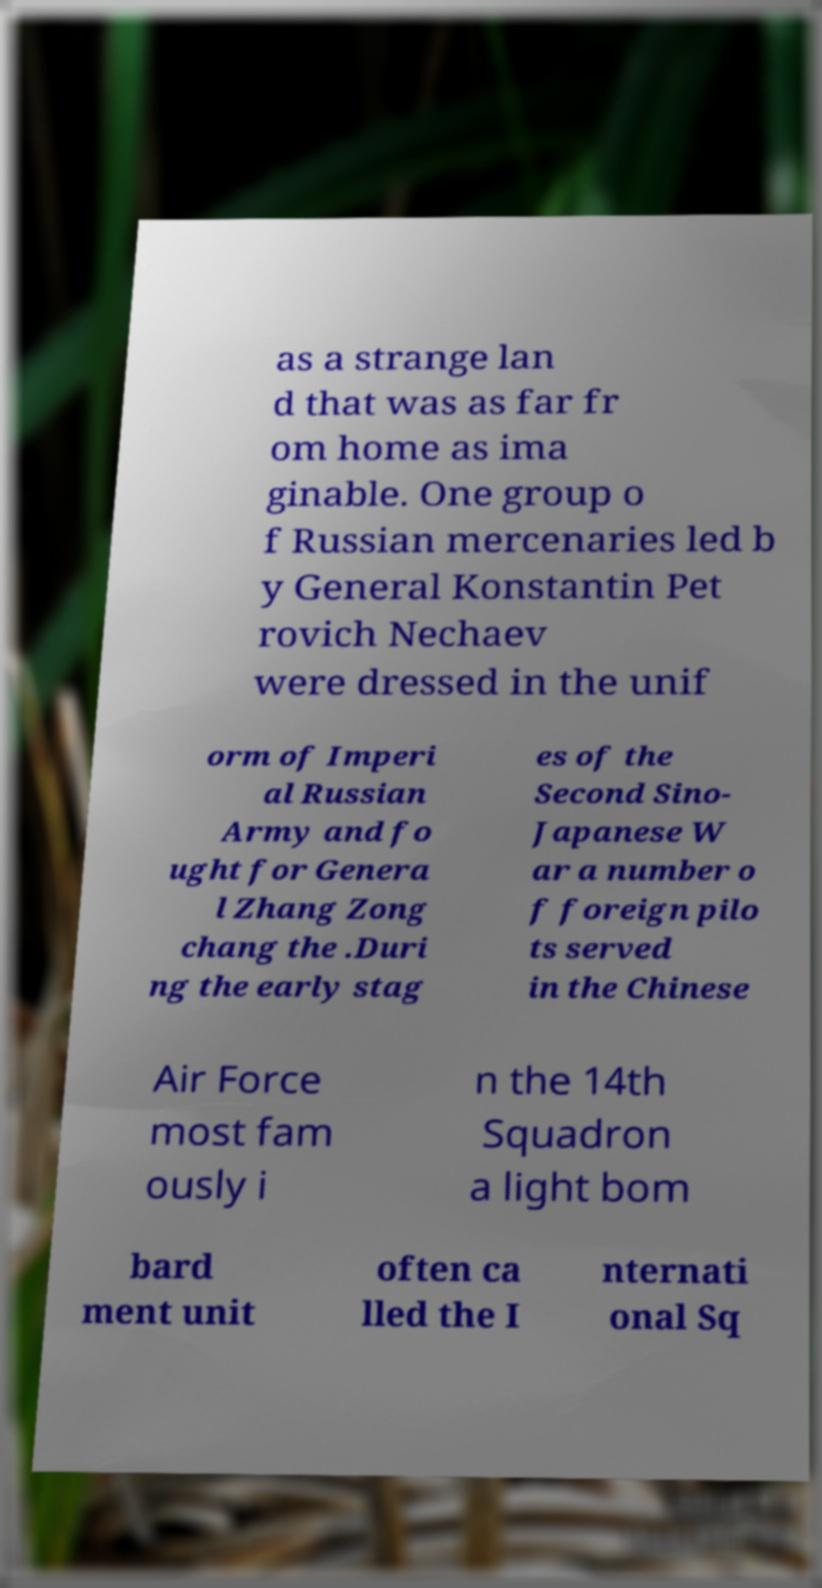I need the written content from this picture converted into text. Can you do that? as a strange lan d that was as far fr om home as ima ginable. One group o f Russian mercenaries led b y General Konstantin Pet rovich Nechaev were dressed in the unif orm of Imperi al Russian Army and fo ught for Genera l Zhang Zong chang the .Duri ng the early stag es of the Second Sino- Japanese W ar a number o f foreign pilo ts served in the Chinese Air Force most fam ously i n the 14th Squadron a light bom bard ment unit often ca lled the I nternati onal Sq 